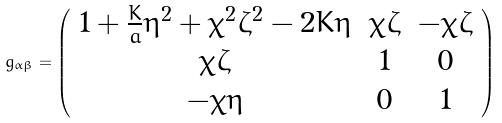Convert formula to latex. <formula><loc_0><loc_0><loc_500><loc_500>g _ { \alpha \beta } = \left ( \begin{array} { c c c } 1 + \frac { K } { a } \eta ^ { 2 } + \chi ^ { 2 } \zeta ^ { 2 } - 2 K \eta & \chi \zeta & - \chi \zeta \\ \chi \zeta & 1 & 0 \\ - \chi \eta & 0 & 1 \end{array} \right )</formula> 